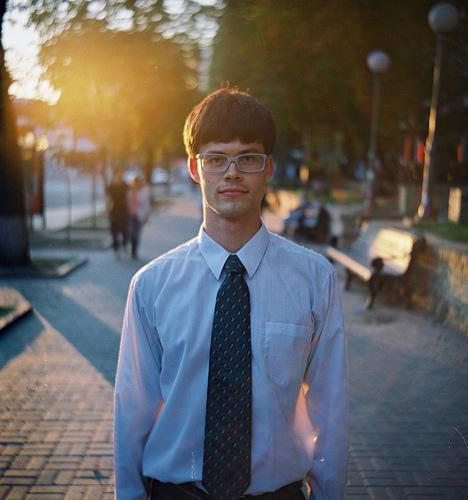What is happening in the background of the image, specifically involving the couple? A couple is walking arm in arm behind the man, creating a lively background scene. Highlight a notable feature of the man's shirt. The white dress shirt has long sleeves and a pocket on the front. Identify two prominent background elements that provide context to the setting. Trees beside the street and lampposts with globes on top give a park-like atmosphere. What type of seating is present in the image and what is it made of? There's a wooden bench with metal legs on the side of the street. Mention the hairstyle of the man and an accessory he is wearing. The man has a bowl haircut and is wearing plastic-framed glasses. Describe the image focusing on the facial features and eyewear of the man. A smiling man with short brown hair and plastic-framed glasses is standing on the street. What kind of environment is the man standing in and what are some notable objects nearby? The man is on a brick sidewalk near a wooden park bench, streetlamps, and trees, with a couple walking in the background. Describe the tie and shirt the man is wearing. The man is wearing a white dress shirt with a pocket, and a blue tie with small designs. Give a quick overview of the scene, focusing on the people present. A young man with glasses stands on a sidewalk, while a couple walks arm in arm behind him. Provide a brief statement describing the main person in the image and their attire. A young man in a white dress shirt and blue tie, wearing glasses, is standing on a brick sidewalk with his arms at his sides. 